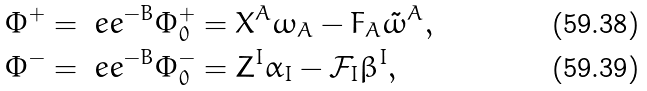Convert formula to latex. <formula><loc_0><loc_0><loc_500><loc_500>\Phi ^ { + } & = \ e e ^ { - B } \Phi ^ { + } _ { 0 } = X ^ { A } \omega _ { A } - F _ { A } \tilde { \omega } ^ { A } , \\ \Phi ^ { - } & = \ e e ^ { - B } \Phi ^ { - } _ { 0 } = Z ^ { I } \alpha _ { I } - \mathcal { F } _ { I } \beta ^ { I } ,</formula> 